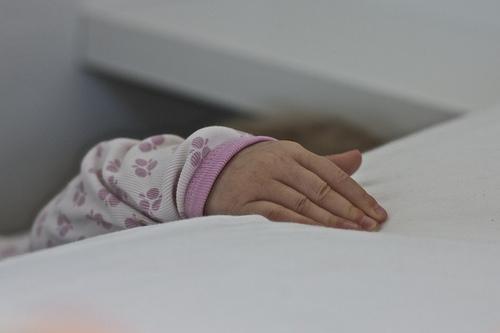How many arms can be seen in the picture?
Give a very brief answer. 1. How many fingers can be seen?
Give a very brief answer. 5. How many people in the photo?
Give a very brief answer. 1. 